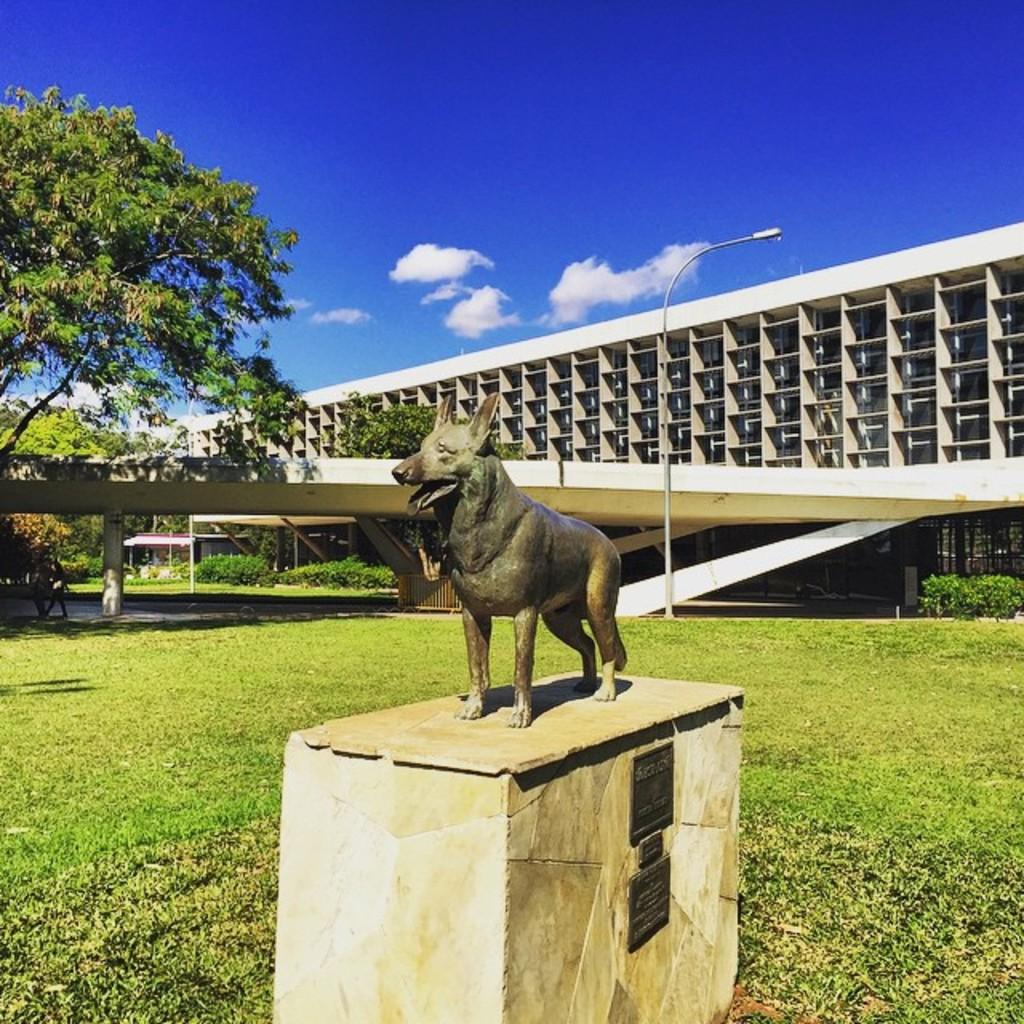What is the main subject in the foreground of the image? There is a statue of a dog on a stone in the foreground of the image. What can be seen in the background of the image? There is a pole, a flyover, a building, a tree, a vehicle, and the sky visible in the background of the image. What is the condition of the sky in the image? The sky is visible in the background of the image, and there are clouds present. What type of polish is being applied to the dog statue in the image? There is no indication in the image that any polish is being applied to the dog statue. How much profit is the statue generating in the image? The image does not depict any commercial activity related to the statue, so it is not possible to determine any profit. 